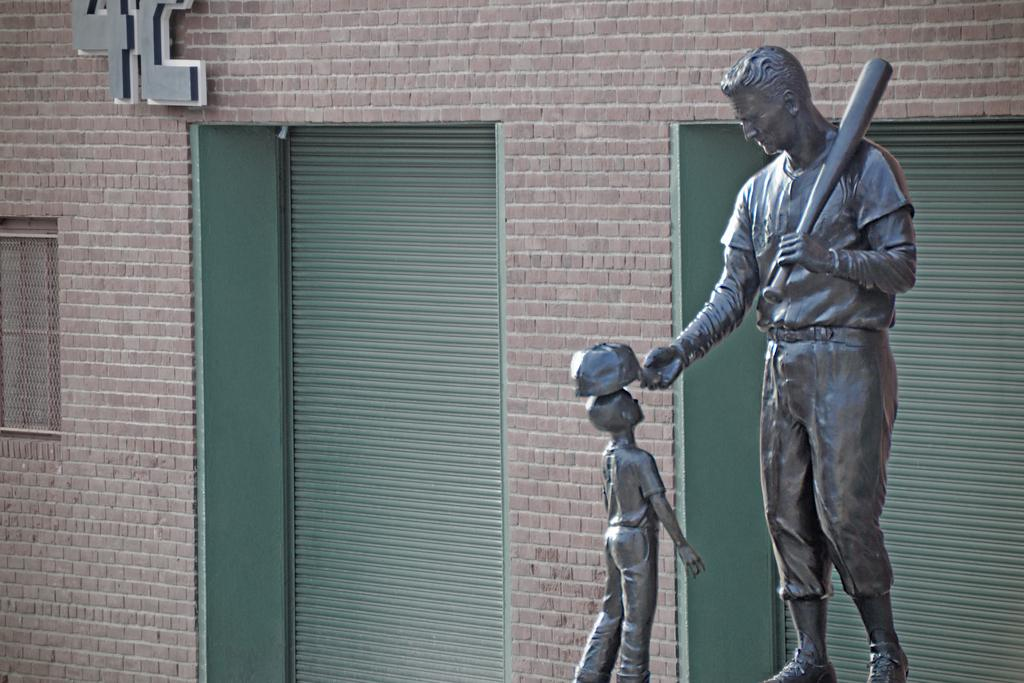What is the main subject in the image? There is a statue in the image. What can be seen in the background of the image? There is a building in the background of the image. What features does the building have? The building has doors and windows. Is there any text visible on the building? Yes, there is a signboard with text on the building. What type of linen is being used to cover the plantation in the image? There is no linen or plantation present in the image. How many steps are visible leading up to the statue in the image? There is no mention of steps or a staircase in the image; the statue is not shown to be elevated. 